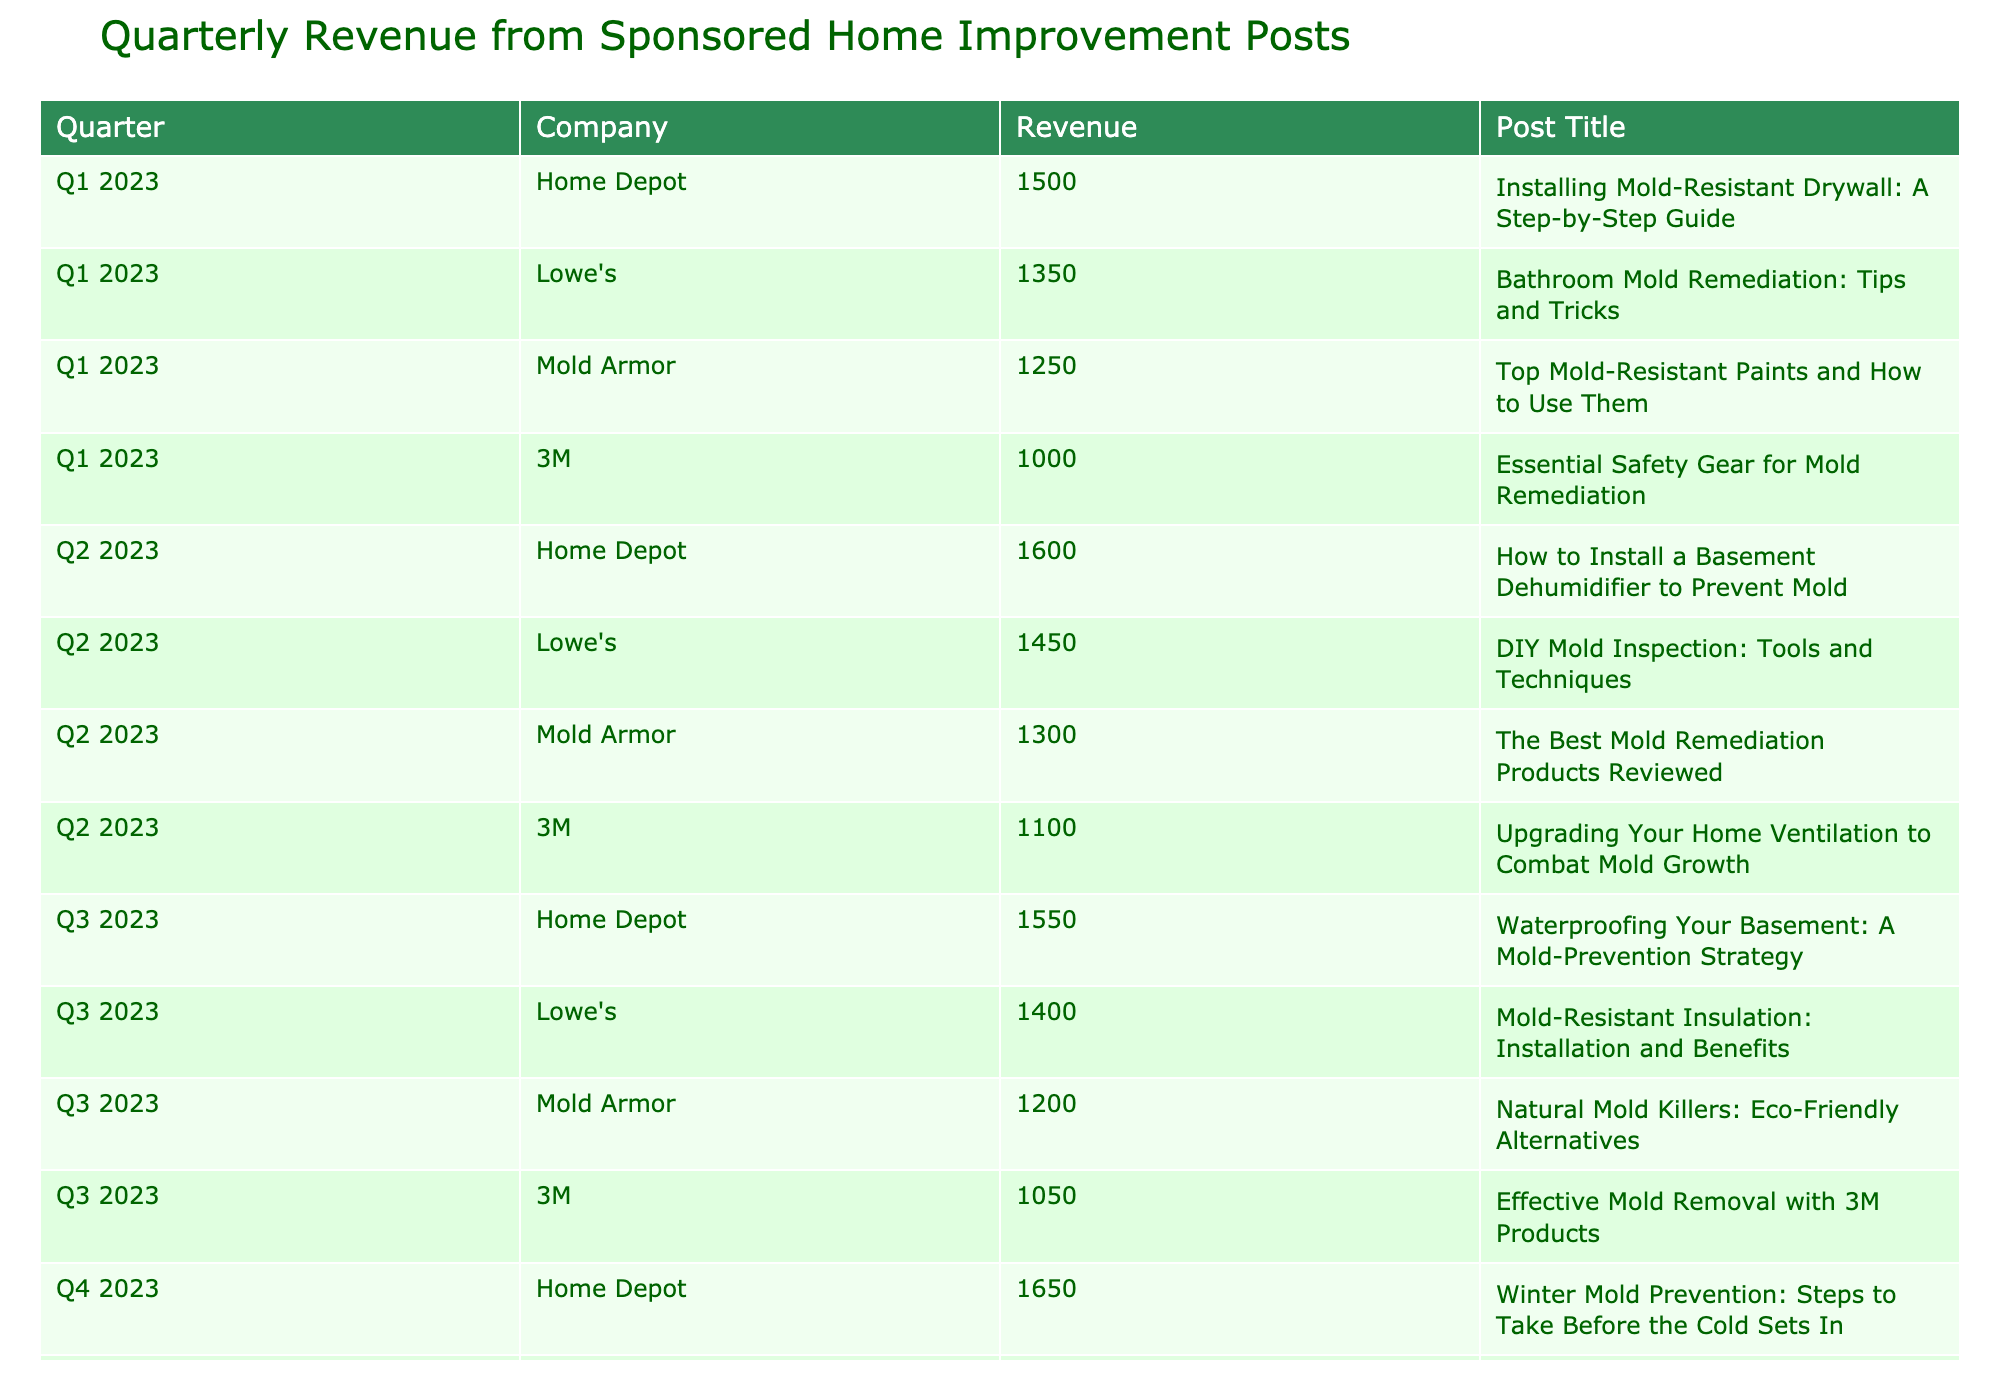What is the highest revenue generated in Q4 2023? Looking at the Q4 2023 data, Home Depot generated 1650, Lowe's generated 1500, Mold Armor generated 1350, and 3M generated 1150. The highest revenue among these is from Home Depot at 1650.
Answer: 1650 What company generated the least revenue in Q2 2023? In Q2 2023, the revenues were Home Depot 1600, Lowe's 1450, Mold Armor 1300, and 3M 1100. The least revenue is from 3M with 1100.
Answer: 3M What was the total revenue from Mold Armor across all quarters? To find the total revenue for Mold Armor, we sum the revenues: Q1 1250, Q2 1300, Q3 1200, and Q4 1350, which equals 1250 + 1300 + 1200 + 1350 = 5100.
Answer: 5100 Is there a post title related to attic mold remediation in Q4 2023? In Q4 2023, Lowe's post title is "Dealing with Attic Mold: Prevention and Removal Methods". Therefore, yes, there is a post related to attic mold remediation.
Answer: Yes Which company had consistent revenue growth from Q1 to Q4 2023? For Home Depot, the revenues are 1500 in Q1, 1600 in Q2, 1550 in Q3, and 1650 in Q4. All values are greater than the previous quarter, showing consistent growth. For Lowe's, the revenue decreased from Q3 to Q4. Therefore, only Home Depot had consistent growth.
Answer: Home Depot 